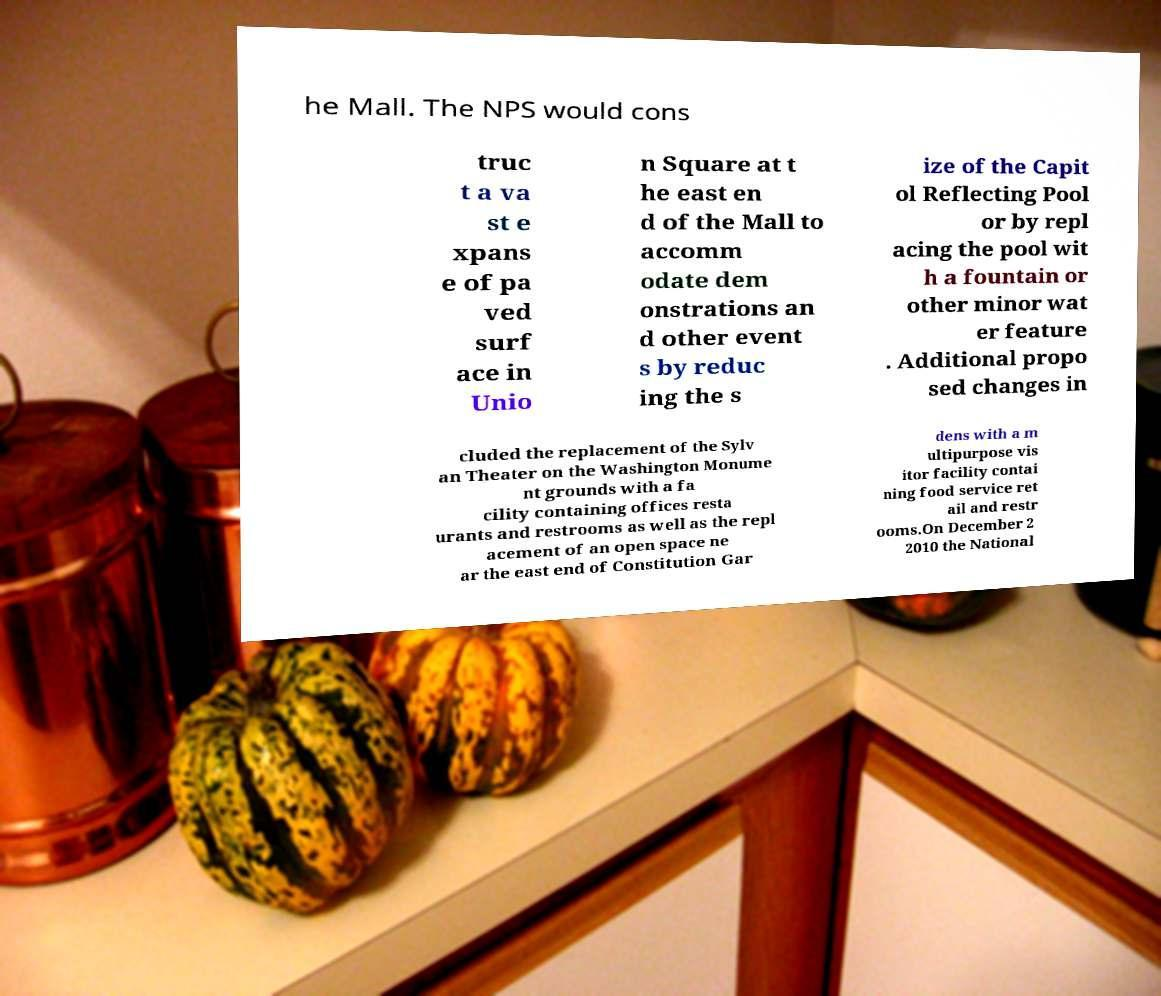I need the written content from this picture converted into text. Can you do that? he Mall. The NPS would cons truc t a va st e xpans e of pa ved surf ace in Unio n Square at t he east en d of the Mall to accomm odate dem onstrations an d other event s by reduc ing the s ize of the Capit ol Reflecting Pool or by repl acing the pool wit h a fountain or other minor wat er feature . Additional propo sed changes in cluded the replacement of the Sylv an Theater on the Washington Monume nt grounds with a fa cility containing offices resta urants and restrooms as well as the repl acement of an open space ne ar the east end of Constitution Gar dens with a m ultipurpose vis itor facility contai ning food service ret ail and restr ooms.On December 2 2010 the National 